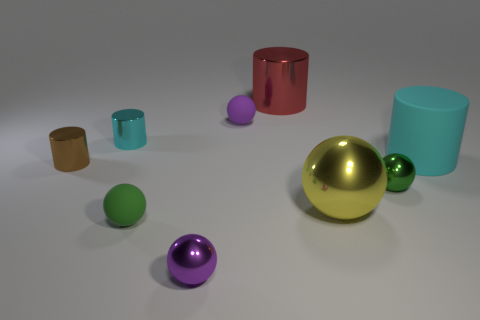Subtract all red cylinders. How many cylinders are left? 3 Subtract all cyan cubes. How many purple spheres are left? 2 Add 1 big red rubber cubes. How many objects exist? 10 Subtract all spheres. How many objects are left? 4 Subtract all green spheres. How many spheres are left? 3 Subtract 2 cylinders. How many cylinders are left? 2 Subtract all cyan matte things. Subtract all brown metallic cylinders. How many objects are left? 7 Add 3 large yellow metal things. How many large yellow metal things are left? 4 Add 6 cyan cylinders. How many cyan cylinders exist? 8 Subtract 1 cyan cylinders. How many objects are left? 8 